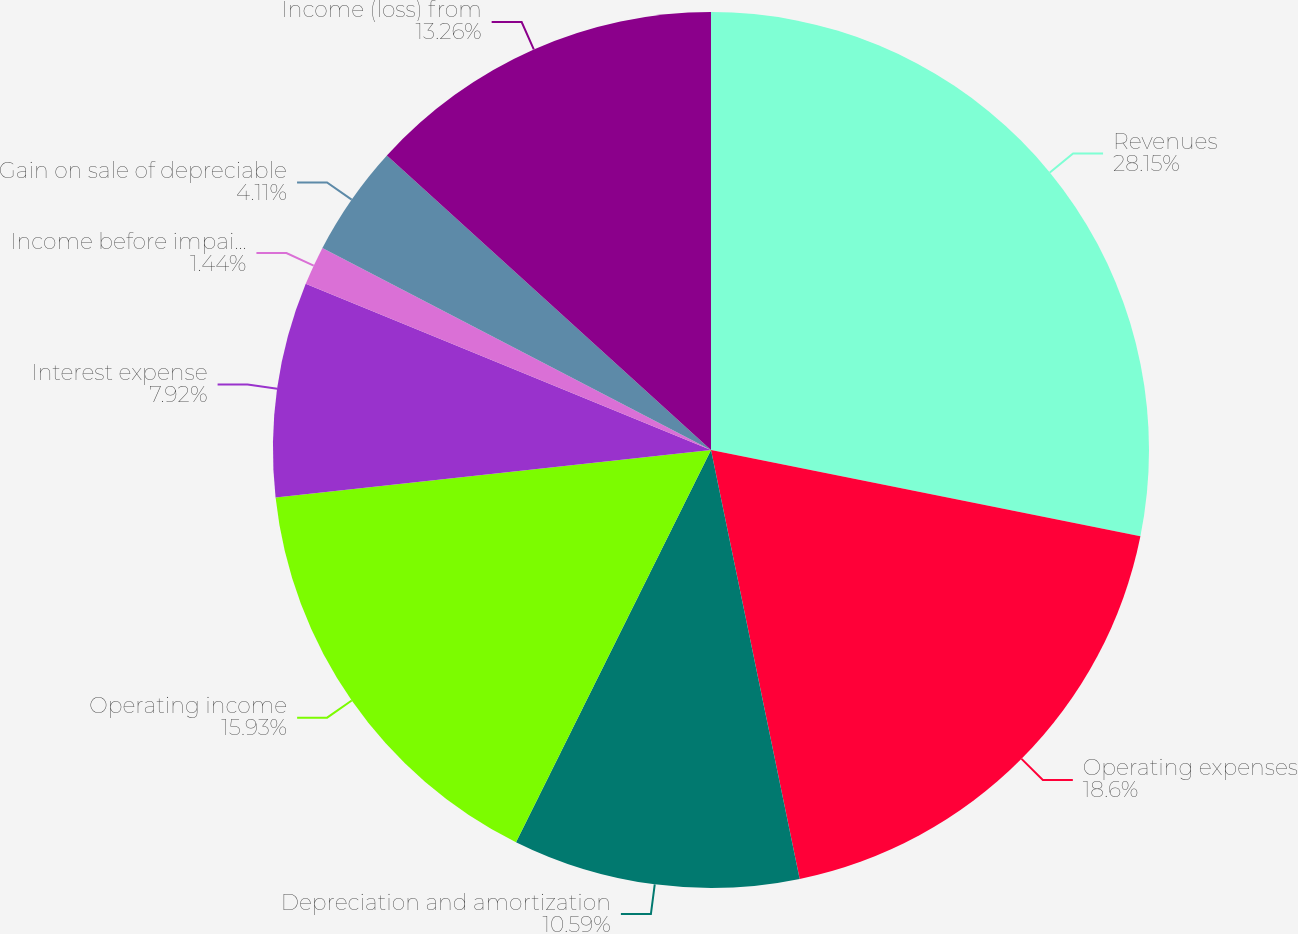Convert chart to OTSL. <chart><loc_0><loc_0><loc_500><loc_500><pie_chart><fcel>Revenues<fcel>Operating expenses<fcel>Depreciation and amortization<fcel>Operating income<fcel>Interest expense<fcel>Income before impairment<fcel>Gain on sale of depreciable<fcel>Income (loss) from<nl><fcel>28.16%<fcel>18.6%<fcel>10.59%<fcel>15.93%<fcel>7.92%<fcel>1.44%<fcel>4.11%<fcel>13.26%<nl></chart> 